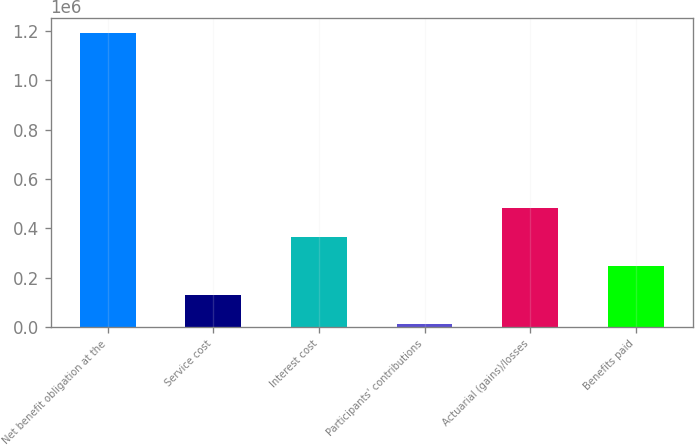Convert chart to OTSL. <chart><loc_0><loc_0><loc_500><loc_500><bar_chart><fcel>Net benefit obligation at the<fcel>Service cost<fcel>Interest cost<fcel>Participants' contributions<fcel>Actuarial (gains)/losses<fcel>Benefits paid<nl><fcel>1.19134e+06<fcel>129587<fcel>365533<fcel>11614<fcel>483506<fcel>247560<nl></chart> 